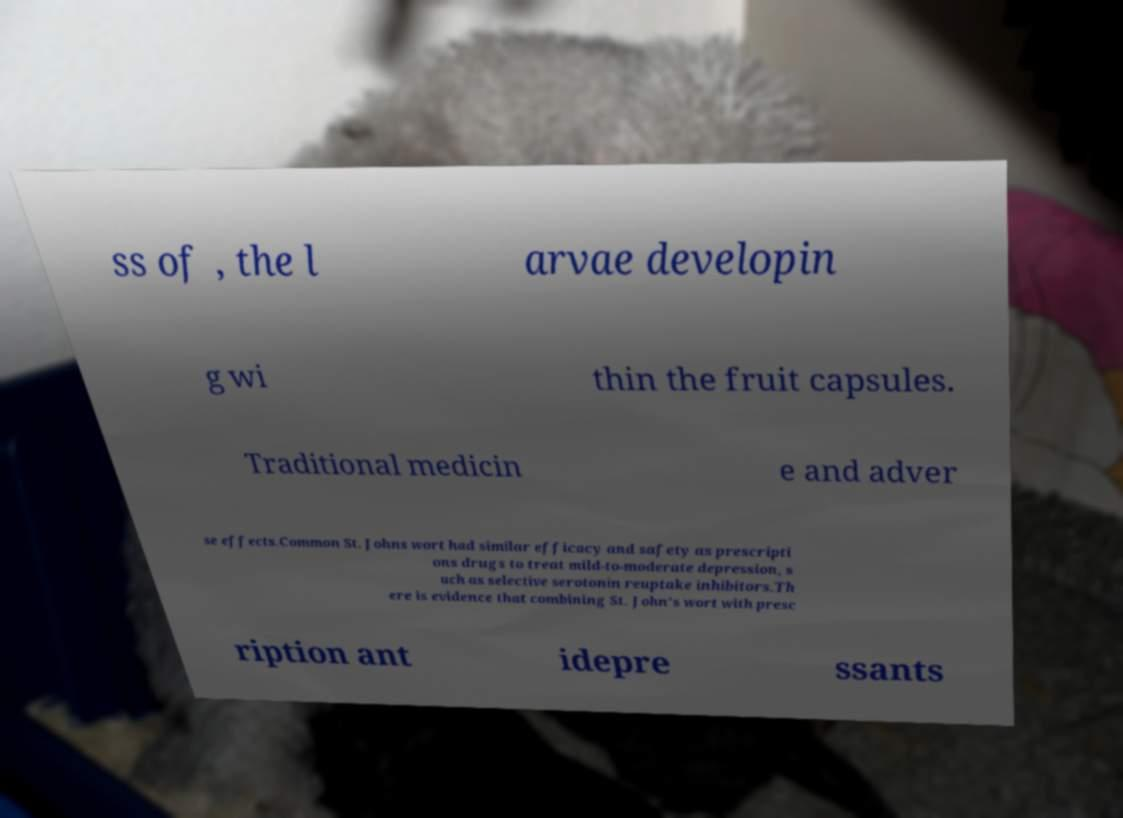For documentation purposes, I need the text within this image transcribed. Could you provide that? ss of , the l arvae developin g wi thin the fruit capsules. Traditional medicin e and adver se effects.Common St. Johns wort had similar efficacy and safety as prescripti ons drugs to treat mild-to-moderate depression, s uch as selective serotonin reuptake inhibitors.Th ere is evidence that combining St. John’s wort with presc ription ant idepre ssants 